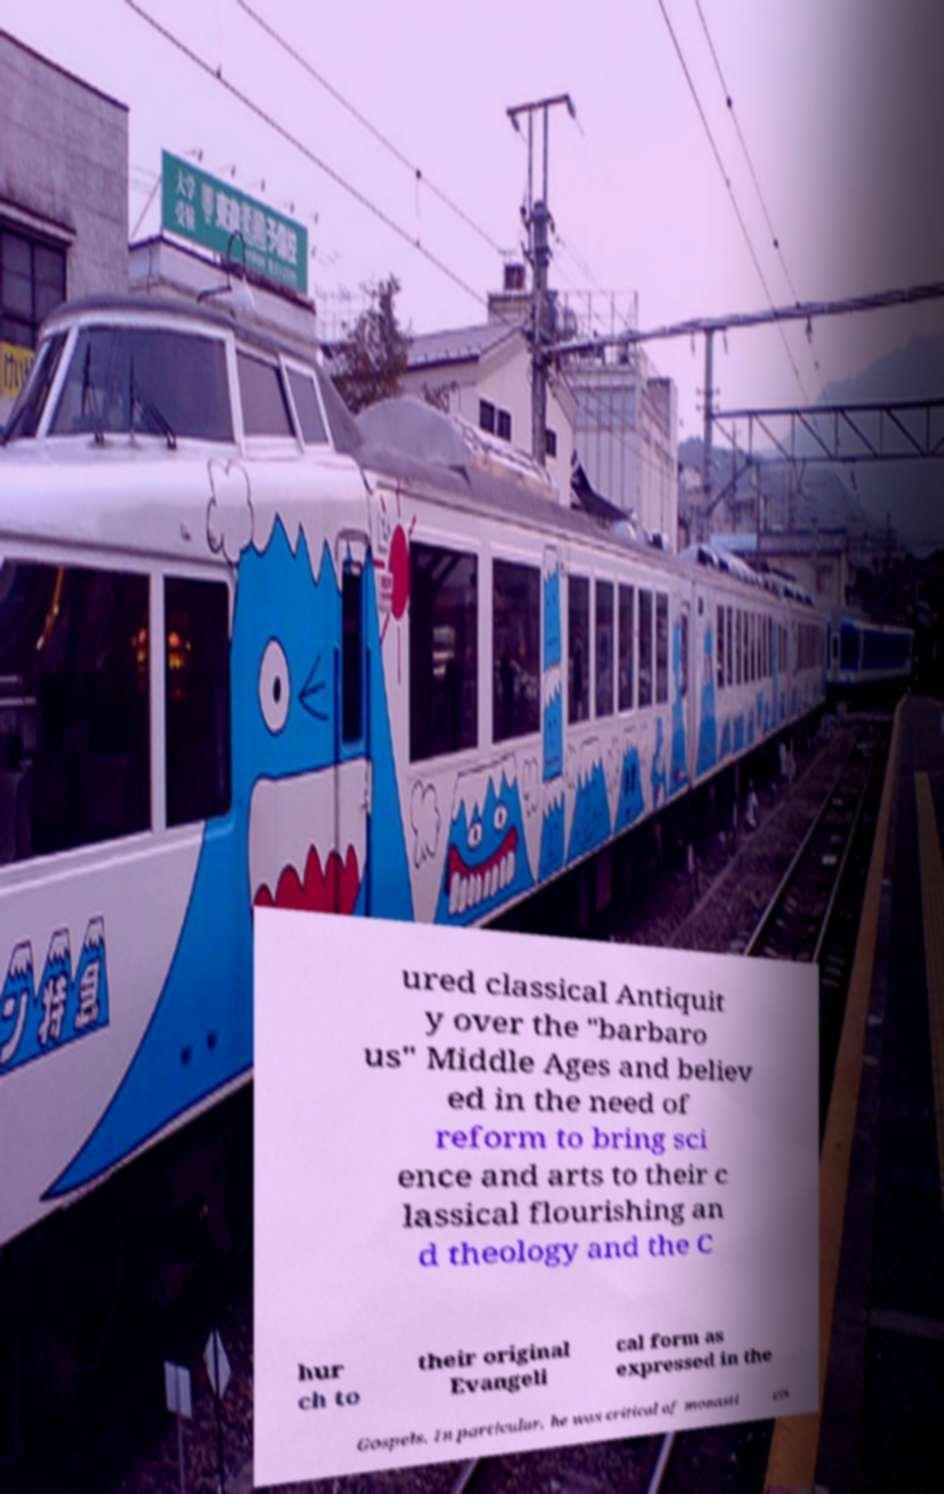For documentation purposes, I need the text within this image transcribed. Could you provide that? ured classical Antiquit y over the "barbaro us" Middle Ages and believ ed in the need of reform to bring sci ence and arts to their c lassical flourishing an d theology and the C hur ch to their original Evangeli cal form as expressed in the Gospels. In particular, he was critical of monasti cis 